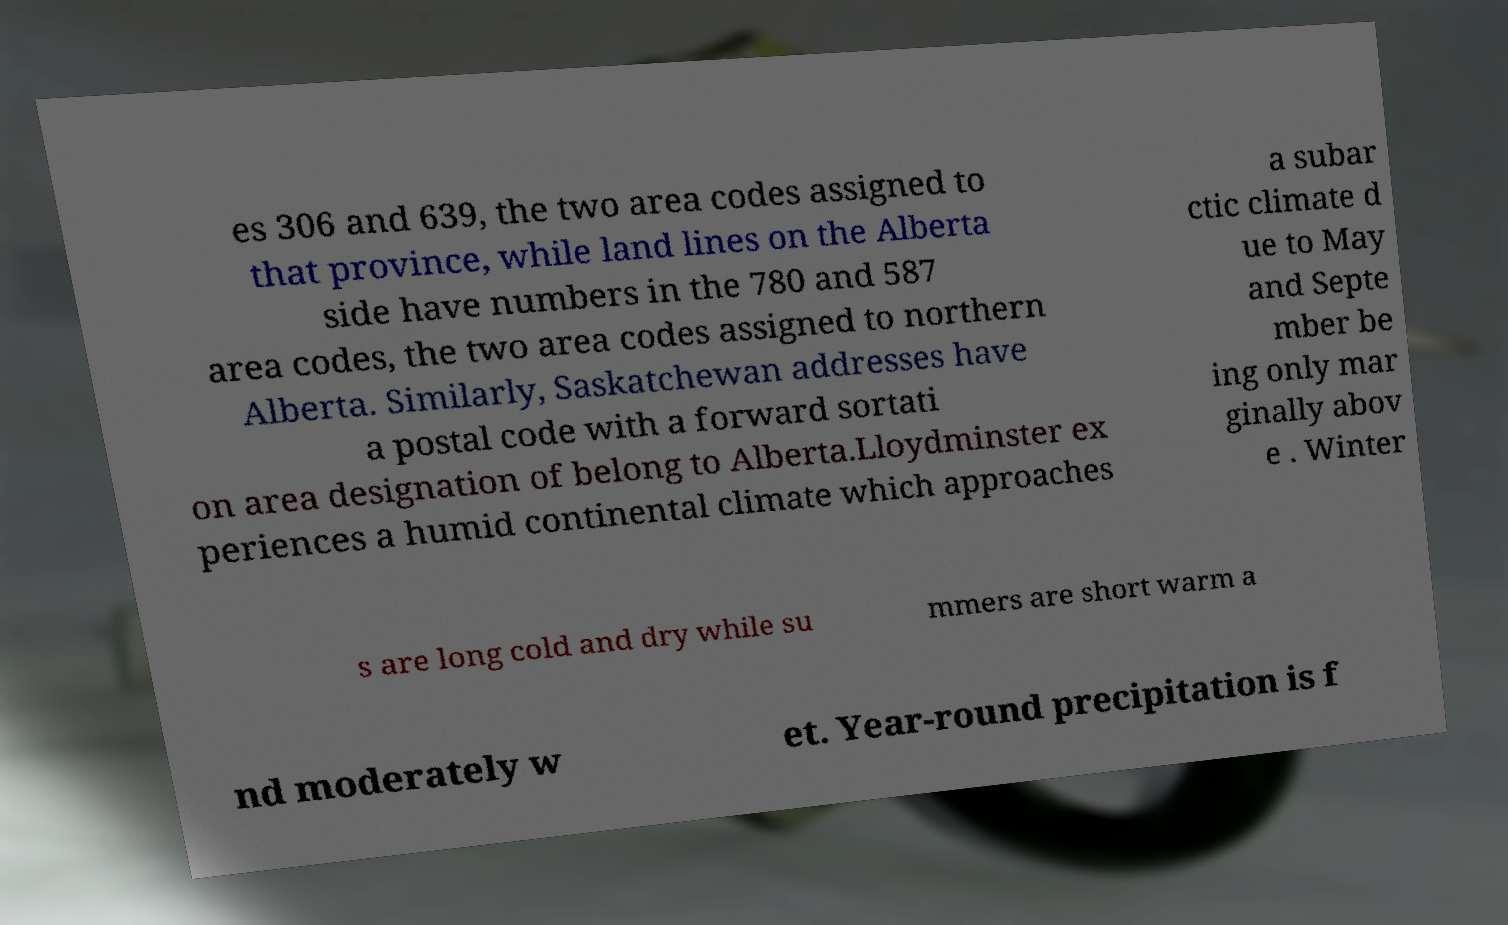Please read and relay the text visible in this image. What does it say? es 306 and 639, the two area codes assigned to that province, while land lines on the Alberta side have numbers in the 780 and 587 area codes, the two area codes assigned to northern Alberta. Similarly, Saskatchewan addresses have a postal code with a forward sortati on area designation of belong to Alberta.Lloydminster ex periences a humid continental climate which approaches a subar ctic climate d ue to May and Septe mber be ing only mar ginally abov e . Winter s are long cold and dry while su mmers are short warm a nd moderately w et. Year-round precipitation is f 